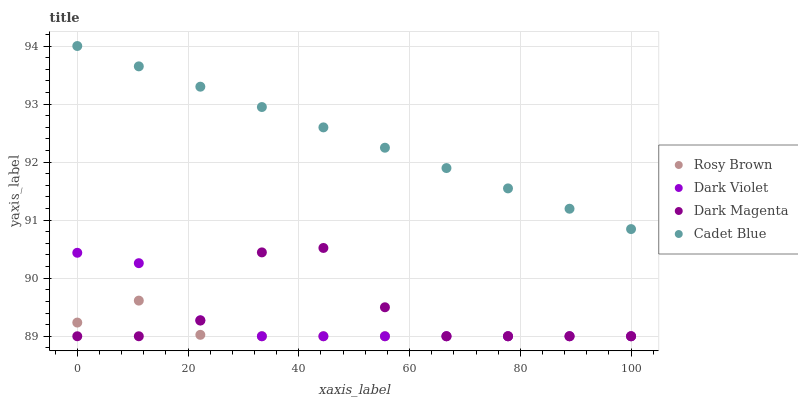Does Rosy Brown have the minimum area under the curve?
Answer yes or no. Yes. Does Cadet Blue have the maximum area under the curve?
Answer yes or no. Yes. Does Dark Magenta have the minimum area under the curve?
Answer yes or no. No. Does Dark Magenta have the maximum area under the curve?
Answer yes or no. No. Is Cadet Blue the smoothest?
Answer yes or no. Yes. Is Dark Magenta the roughest?
Answer yes or no. Yes. Is Rosy Brown the smoothest?
Answer yes or no. No. Is Rosy Brown the roughest?
Answer yes or no. No. Does Rosy Brown have the lowest value?
Answer yes or no. Yes. Does Cadet Blue have the highest value?
Answer yes or no. Yes. Does Dark Magenta have the highest value?
Answer yes or no. No. Is Dark Violet less than Cadet Blue?
Answer yes or no. Yes. Is Cadet Blue greater than Dark Magenta?
Answer yes or no. Yes. Does Dark Magenta intersect Dark Violet?
Answer yes or no. Yes. Is Dark Magenta less than Dark Violet?
Answer yes or no. No. Is Dark Magenta greater than Dark Violet?
Answer yes or no. No. Does Dark Violet intersect Cadet Blue?
Answer yes or no. No. 